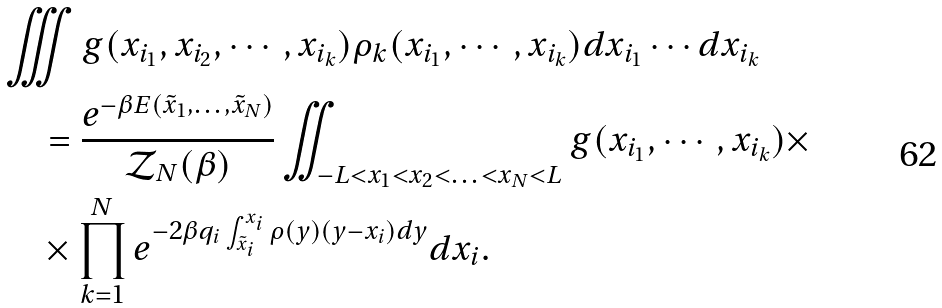Convert formula to latex. <formula><loc_0><loc_0><loc_500><loc_500>& \iiint g ( x _ { i _ { 1 } } , x _ { i _ { 2 } } , \cdots , x _ { i _ { k } } ) \rho _ { k } ( x _ { i _ { 1 } } , \cdots , x _ { i _ { k } } ) d x _ { i _ { 1 } } \cdots d x _ { i _ { k } } \\ & \quad = \frac { e ^ { - \beta E ( \tilde { x } _ { 1 } , \text {\dots} , \tilde { x } _ { N } ) } } { \mathcal { Z } _ { N } ( \beta ) } \iint _ { - L < x _ { 1 } < x _ { 2 } < \text {\dots} < x _ { N } < L } g ( x _ { i _ { 1 } } , \cdots , x _ { i _ { k } } ) \times \\ & \quad \times \prod _ { k = 1 } ^ { N } e ^ { - 2 \beta q _ { i } \int _ { \tilde { x } _ { i } } ^ { x _ { i } } \rho ( y ) ( y - x _ { i } ) d y } d x _ { i } .</formula> 